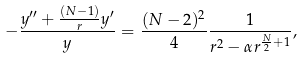<formula> <loc_0><loc_0><loc_500><loc_500>- \frac { y ^ { \prime \prime } + \frac { ( N - 1 ) } { r } y ^ { \prime } } { y } = \frac { ( N - 2 ) ^ { 2 } } { 4 } \frac { 1 } { r ^ { 2 } - \alpha r ^ { \frac { N } { 2 } + 1 } } ,</formula> 